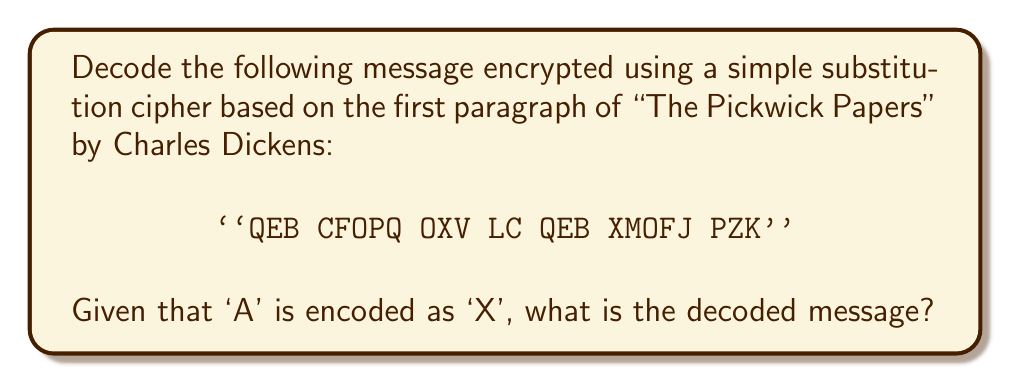Solve this math problem. To solve this problem, we need to follow these steps:

1. Recognize that this is a simple substitution cipher where each letter is replaced by another letter consistently throughout the message.

2. We are given that 'A' is encoded as 'X'. This suggests a shift in the alphabet.

3. To determine the shift, we can calculate:
   $$(ASCII\text{ value of 'X'}) - (ASCII\text{ value of 'A'}) = 88 - 65 = 23$$

4. This indicates a shift of 23 places in the alphabet. To decode, we need to shift each letter back by 23 places.

5. We can use the formula:
   $$D_i = (E_i - 23 + 26) \mod 26$$
   Where $D_i$ is the decoded letter and $E_i$ is the encoded letter (both represented by their position in the alphabet, A=0, B=1, etc.)

6. Applying this to each letter:
   Q -> T
   E -> H
   B -> E
   
   C -> F
   F -> I
   O -> R
   P -> S
   Q -> T
   
   O -> R
   X -> A
   V -> Y
   
   L -> O
   C -> F
   
   Q -> T
   E -> H
   B -> E
   
   X -> A
   M -> P
   O -> R
   F -> I
   J -> L
   
   P -> S
   Z -> C
   K -> N

7. Combining these decoded letters, we get the message.
Answer: THE FIRST RAY OF THE APRIL SUN 